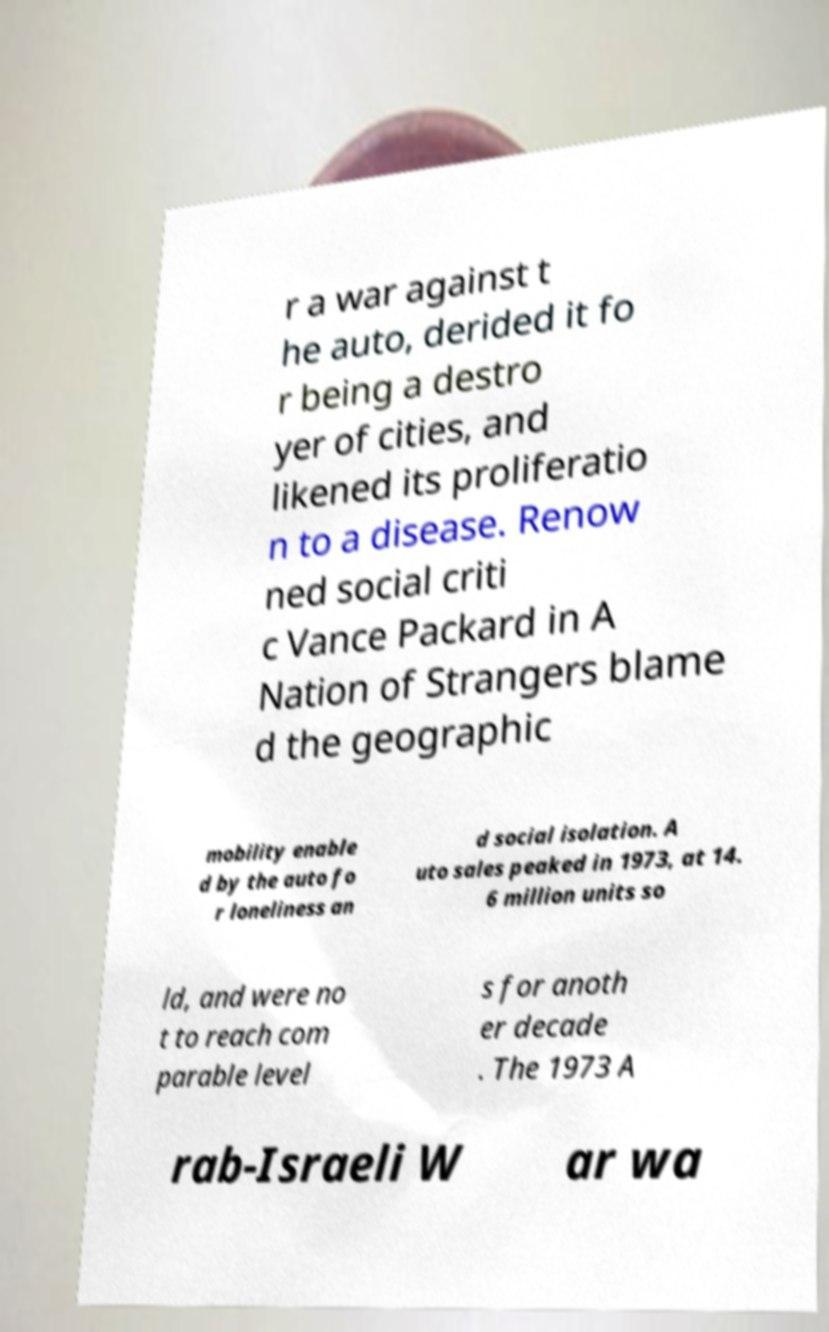Please read and relay the text visible in this image. What does it say? r a war against t he auto, derided it fo r being a destro yer of cities, and likened its proliferatio n to a disease. Renow ned social criti c Vance Packard in A Nation of Strangers blame d the geographic mobility enable d by the auto fo r loneliness an d social isolation. A uto sales peaked in 1973, at 14. 6 million units so ld, and were no t to reach com parable level s for anoth er decade . The 1973 A rab-Israeli W ar wa 